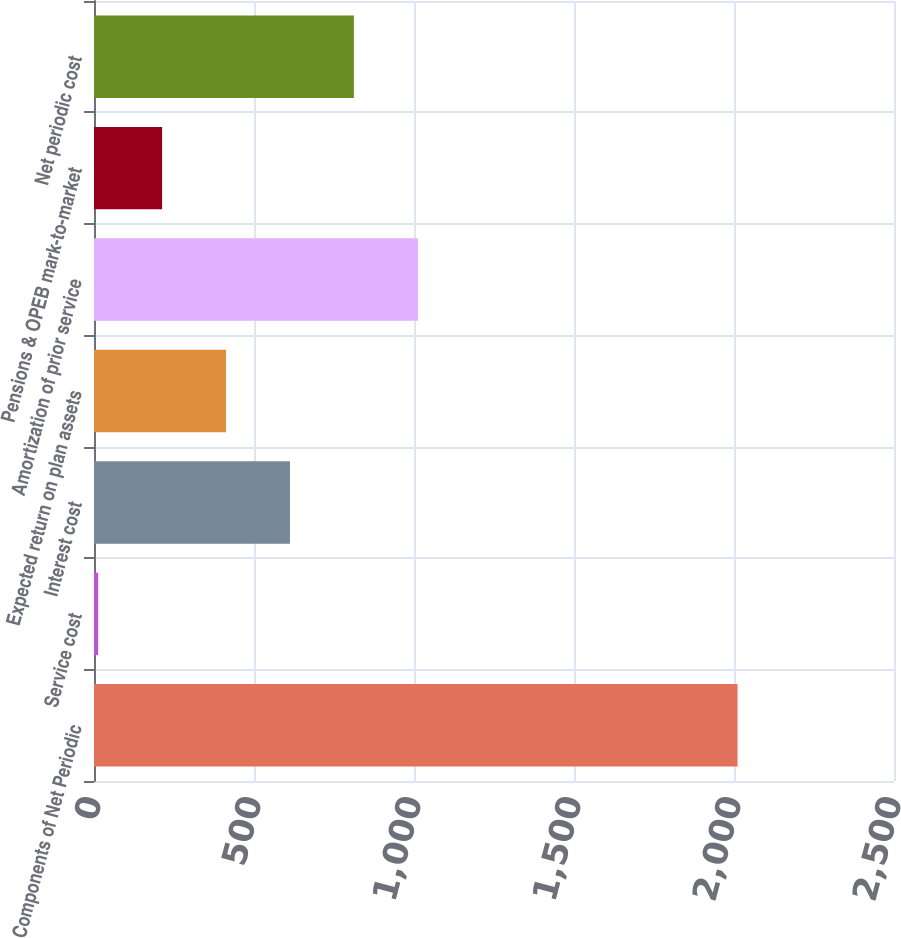Convert chart. <chart><loc_0><loc_0><loc_500><loc_500><bar_chart><fcel>Components of Net Periodic<fcel>Service cost<fcel>Interest cost<fcel>Expected return on plan assets<fcel>Amortization of prior service<fcel>Pensions & OPEB mark-to-market<fcel>Net periodic cost<nl><fcel>2011<fcel>13<fcel>612.4<fcel>412.6<fcel>1012<fcel>212.8<fcel>812.2<nl></chart> 